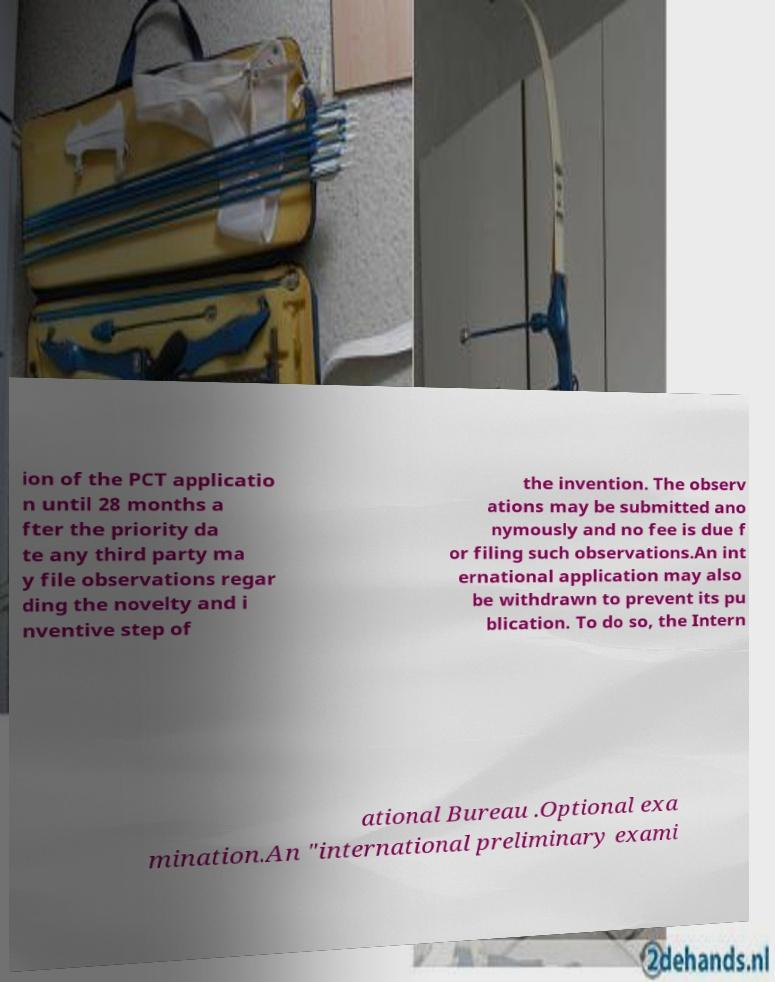For documentation purposes, I need the text within this image transcribed. Could you provide that? ion of the PCT applicatio n until 28 months a fter the priority da te any third party ma y file observations regar ding the novelty and i nventive step of the invention. The observ ations may be submitted ano nymously and no fee is due f or filing such observations.An int ernational application may also be withdrawn to prevent its pu blication. To do so, the Intern ational Bureau .Optional exa mination.An "international preliminary exami 